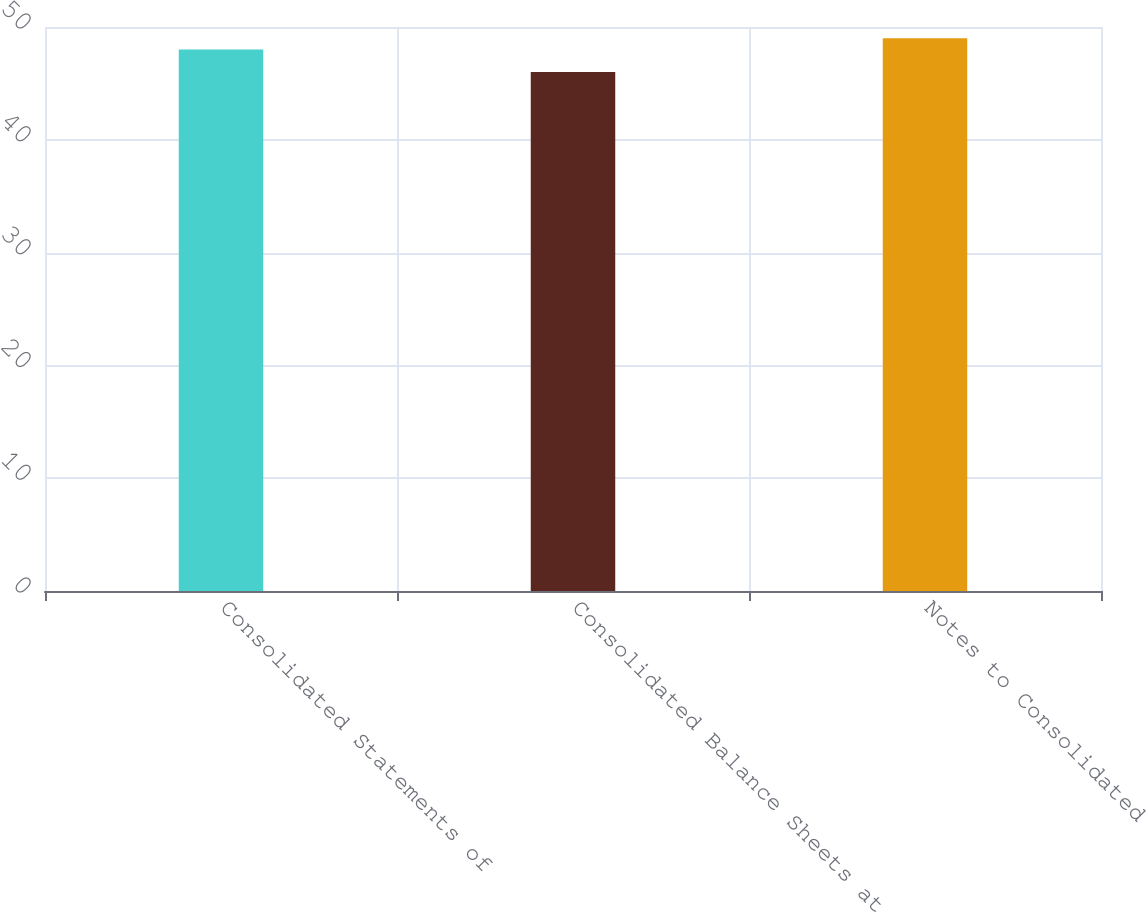Convert chart to OTSL. <chart><loc_0><loc_0><loc_500><loc_500><bar_chart><fcel>Consolidated Statements of<fcel>Consolidated Balance Sheets at<fcel>Notes to Consolidated<nl><fcel>48<fcel>46<fcel>49<nl></chart> 